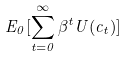<formula> <loc_0><loc_0><loc_500><loc_500>E _ { 0 } [ \sum _ { t = 0 } ^ { \infty } \beta ^ { t } U ( c _ { t } ) ]</formula> 